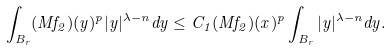<formula> <loc_0><loc_0><loc_500><loc_500>\int _ { B _ { r } } ( M f _ { 2 } ) ( y ) ^ { p } | y | ^ { \lambda - n } d y \leq C _ { 1 } ( M f _ { 2 } ) ( x ) ^ { p } \int _ { B _ { r } } | y | ^ { \lambda - n } d y .</formula> 